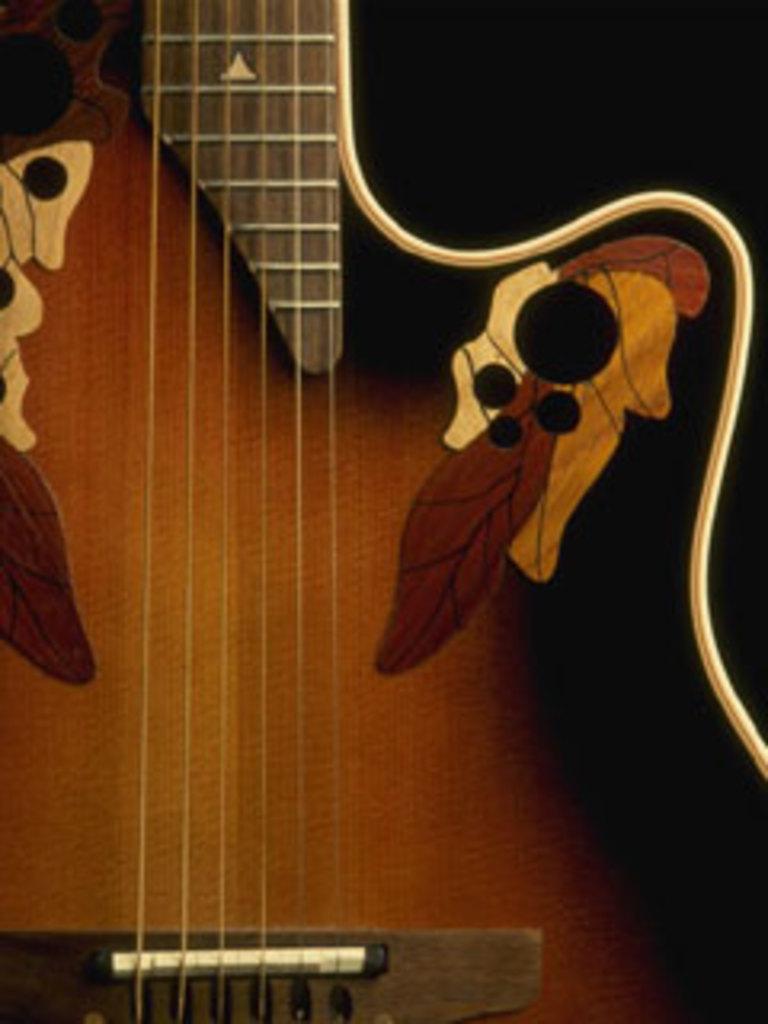In one or two sentences, can you explain what this image depicts? This picture contains guitar which is brown in color. 